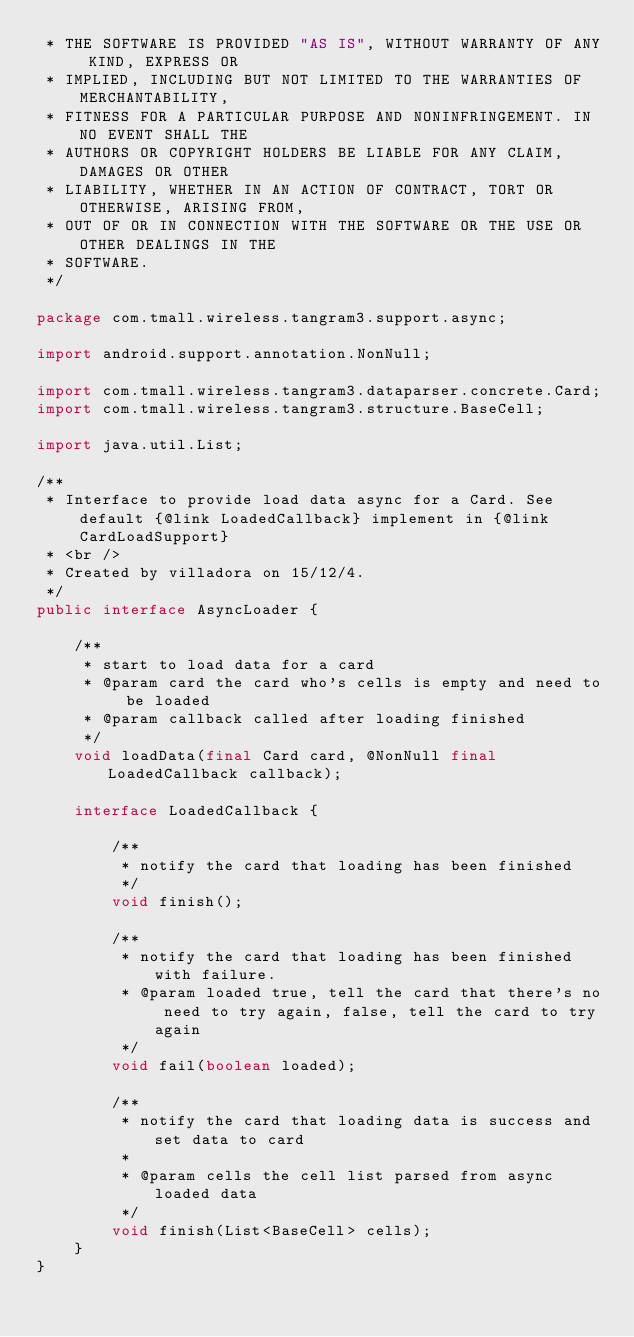Convert code to text. <code><loc_0><loc_0><loc_500><loc_500><_Java_> * THE SOFTWARE IS PROVIDED "AS IS", WITHOUT WARRANTY OF ANY KIND, EXPRESS OR
 * IMPLIED, INCLUDING BUT NOT LIMITED TO THE WARRANTIES OF MERCHANTABILITY,
 * FITNESS FOR A PARTICULAR PURPOSE AND NONINFRINGEMENT. IN NO EVENT SHALL THE
 * AUTHORS OR COPYRIGHT HOLDERS BE LIABLE FOR ANY CLAIM, DAMAGES OR OTHER
 * LIABILITY, WHETHER IN AN ACTION OF CONTRACT, TORT OR OTHERWISE, ARISING FROM,
 * OUT OF OR IN CONNECTION WITH THE SOFTWARE OR THE USE OR OTHER DEALINGS IN THE
 * SOFTWARE.
 */

package com.tmall.wireless.tangram3.support.async;

import android.support.annotation.NonNull;

import com.tmall.wireless.tangram3.dataparser.concrete.Card;
import com.tmall.wireless.tangram3.structure.BaseCell;

import java.util.List;

/**
 * Interface to provide load data async for a Card. See default {@link LoadedCallback} implement in {@link CardLoadSupport}
 * <br />
 * Created by villadora on 15/12/4.
 */
public interface AsyncLoader {

    /**
     * start to load data for a card
     * @param card the card who's cells is empty and need to be loaded
     * @param callback called after loading finished
     */
    void loadData(final Card card, @NonNull final LoadedCallback callback);

    interface LoadedCallback {

        /**
         * notify the card that loading has been finished
         */
        void finish();

        /**
         * notify the card that loading has been finished with failure.
         * @param loaded true, tell the card that there's no need to try again, false, tell the card to try again
         */
        void fail(boolean loaded);

        /**
         * notify the card that loading data is success and set data to card
         *
         * @param cells the cell list parsed from async loaded data
         */
        void finish(List<BaseCell> cells);
    }
}
</code> 